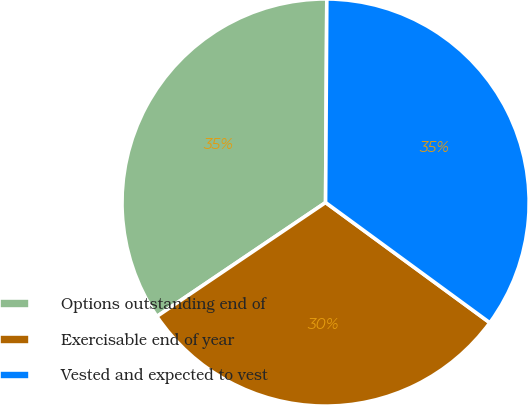Convert chart. <chart><loc_0><loc_0><loc_500><loc_500><pie_chart><fcel>Options outstanding end of<fcel>Exercisable end of year<fcel>Vested and expected to vest<nl><fcel>34.55%<fcel>30.49%<fcel>34.96%<nl></chart> 